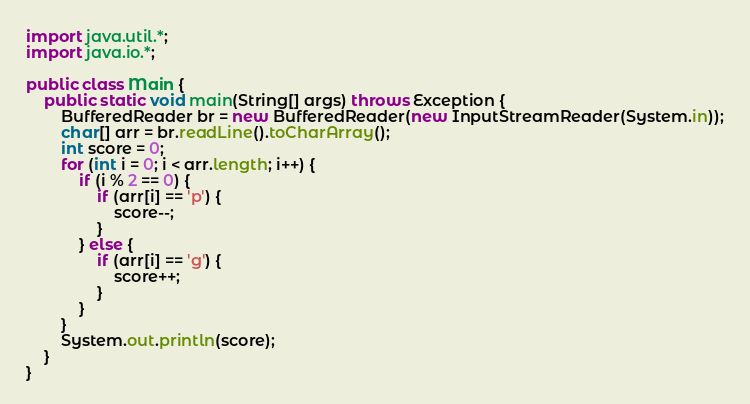Convert code to text. <code><loc_0><loc_0><loc_500><loc_500><_Java_>import java.util.*;
import java.io.*;

public class Main {
    public static void main(String[] args) throws Exception {
        BufferedReader br = new BufferedReader(new InputStreamReader(System.in));
        char[] arr = br.readLine().toCharArray();
        int score = 0;
        for (int i = 0; i < arr.length; i++) {
            if (i % 2 == 0) {
                if (arr[i] == 'p') {
                    score--;
                }
            } else {
                if (arr[i] == 'g') {
                    score++;
                }
            }
        }
        System.out.println(score);
    }
}</code> 